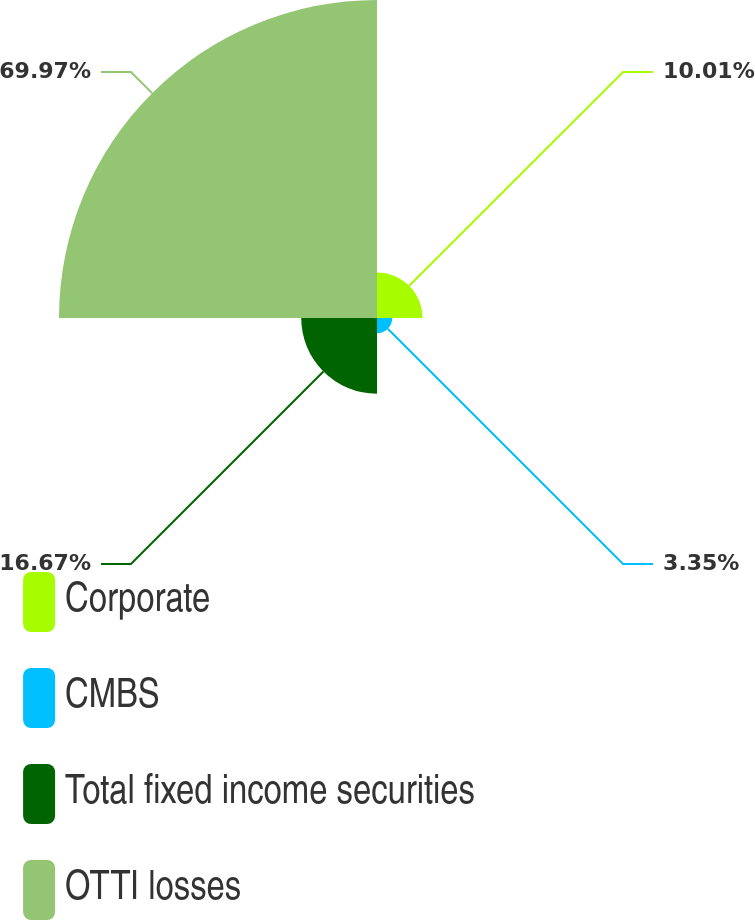Convert chart to OTSL. <chart><loc_0><loc_0><loc_500><loc_500><pie_chart><fcel>Corporate<fcel>CMBS<fcel>Total fixed income securities<fcel>OTTI losses<nl><fcel>10.01%<fcel>3.35%<fcel>16.67%<fcel>69.96%<nl></chart> 